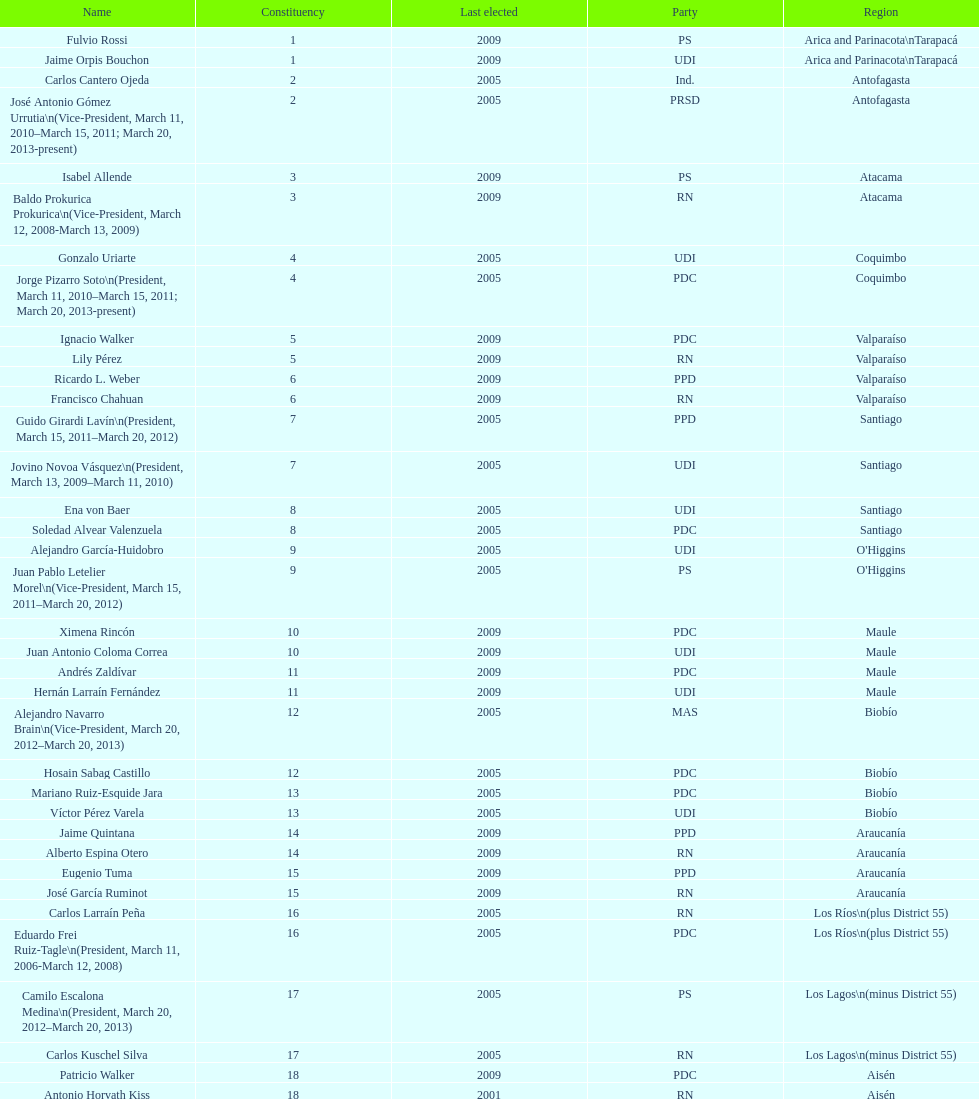How long was baldo prokurica prokurica vice-president? 1 year. Would you be able to parse every entry in this table? {'header': ['Name', 'Constituency', 'Last elected', 'Party', 'Region'], 'rows': [['Fulvio Rossi', '1', '2009', 'PS', 'Arica and Parinacota\\nTarapacá'], ['Jaime Orpis Bouchon', '1', '2009', 'UDI', 'Arica and Parinacota\\nTarapacá'], ['Carlos Cantero Ojeda', '2', '2005', 'Ind.', 'Antofagasta'], ['José Antonio Gómez Urrutia\\n(Vice-President, March 11, 2010–March 15, 2011; March 20, 2013-present)', '2', '2005', 'PRSD', 'Antofagasta'], ['Isabel Allende', '3', '2009', 'PS', 'Atacama'], ['Baldo Prokurica Prokurica\\n(Vice-President, March 12, 2008-March 13, 2009)', '3', '2009', 'RN', 'Atacama'], ['Gonzalo Uriarte', '4', '2005', 'UDI', 'Coquimbo'], ['Jorge Pizarro Soto\\n(President, March 11, 2010–March 15, 2011; March 20, 2013-present)', '4', '2005', 'PDC', 'Coquimbo'], ['Ignacio Walker', '5', '2009', 'PDC', 'Valparaíso'], ['Lily Pérez', '5', '2009', 'RN', 'Valparaíso'], ['Ricardo L. Weber', '6', '2009', 'PPD', 'Valparaíso'], ['Francisco Chahuan', '6', '2009', 'RN', 'Valparaíso'], ['Guido Girardi Lavín\\n(President, March 15, 2011–March 20, 2012)', '7', '2005', 'PPD', 'Santiago'], ['Jovino Novoa Vásquez\\n(President, March 13, 2009–March 11, 2010)', '7', '2005', 'UDI', 'Santiago'], ['Ena von Baer', '8', '2005', 'UDI', 'Santiago'], ['Soledad Alvear Valenzuela', '8', '2005', 'PDC', 'Santiago'], ['Alejandro García-Huidobro', '9', '2005', 'UDI', "O'Higgins"], ['Juan Pablo Letelier Morel\\n(Vice-President, March 15, 2011–March 20, 2012)', '9', '2005', 'PS', "O'Higgins"], ['Ximena Rincón', '10', '2009', 'PDC', 'Maule'], ['Juan Antonio Coloma Correa', '10', '2009', 'UDI', 'Maule'], ['Andrés Zaldívar', '11', '2009', 'PDC', 'Maule'], ['Hernán Larraín Fernández', '11', '2009', 'UDI', 'Maule'], ['Alejandro Navarro Brain\\n(Vice-President, March 20, 2012–March 20, 2013)', '12', '2005', 'MAS', 'Biobío'], ['Hosain Sabag Castillo', '12', '2005', 'PDC', 'Biobío'], ['Mariano Ruiz-Esquide Jara', '13', '2005', 'PDC', 'Biobío'], ['Víctor Pérez Varela', '13', '2005', 'UDI', 'Biobío'], ['Jaime Quintana', '14', '2009', 'PPD', 'Araucanía'], ['Alberto Espina Otero', '14', '2009', 'RN', 'Araucanía'], ['Eugenio Tuma', '15', '2009', 'PPD', 'Araucanía'], ['José García Ruminot', '15', '2009', 'RN', 'Araucanía'], ['Carlos Larraín Peña', '16', '2005', 'RN', 'Los Ríos\\n(plus District 55)'], ['Eduardo Frei Ruiz-Tagle\\n(President, March 11, 2006-March 12, 2008)', '16', '2005', 'PDC', 'Los Ríos\\n(plus District 55)'], ['Camilo Escalona Medina\\n(President, March 20, 2012–March 20, 2013)', '17', '2005', 'PS', 'Los Lagos\\n(minus District 55)'], ['Carlos Kuschel Silva', '17', '2005', 'RN', 'Los Lagos\\n(minus District 55)'], ['Patricio Walker', '18', '2009', 'PDC', 'Aisén'], ['Antonio Horvath Kiss', '18', '2001', 'RN', 'Aisén'], ['Carlos Bianchi Chelech\\n(Vice-President, March 13, 2009–March 11, 2010)', '19', '2005', 'Ind.', 'Magallanes'], ['Pedro Muñoz Aburto', '19', '2005', 'PS', 'Magallanes']]} 